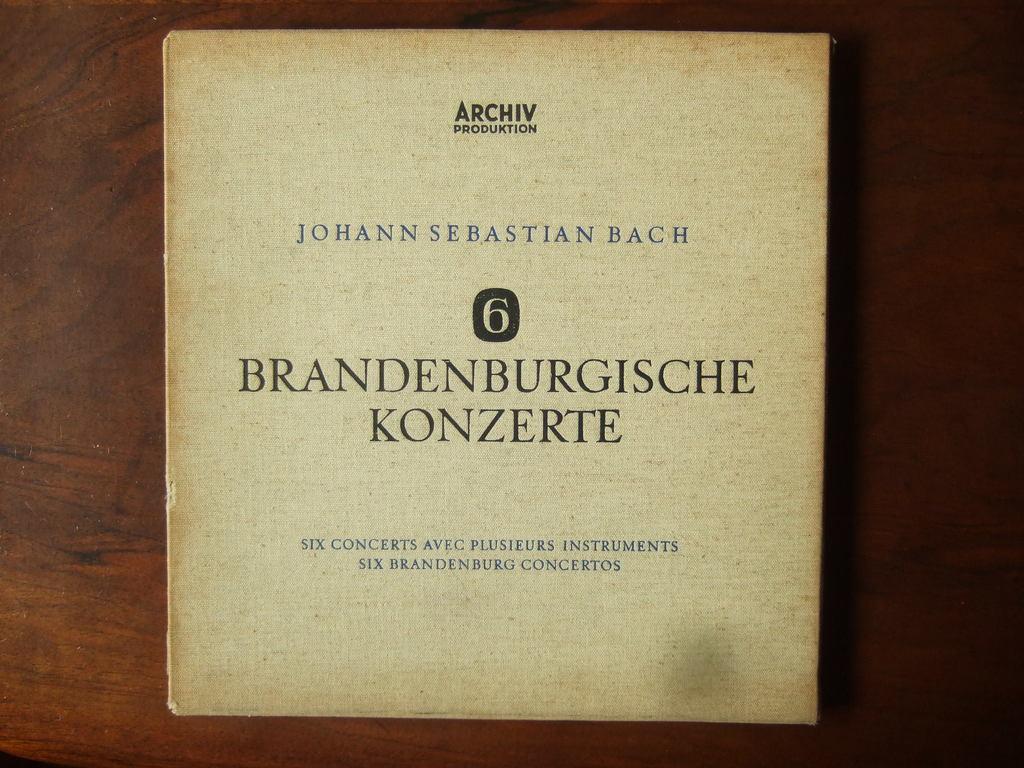How would you summarize this image in a sentence or two? In this image, we can see a book on the table. 